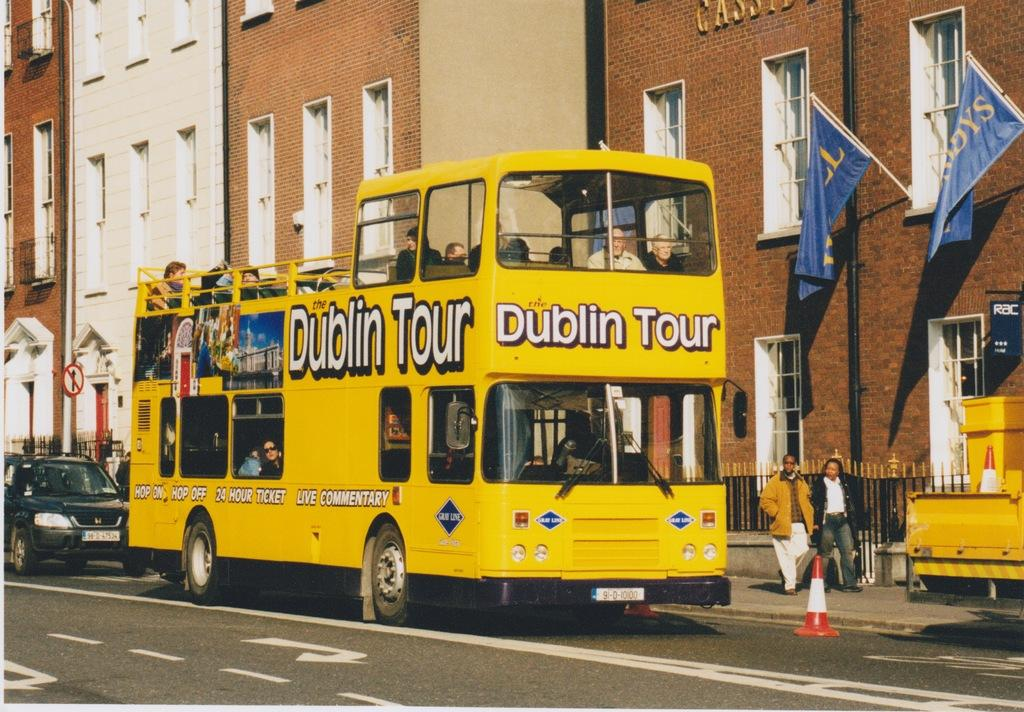<image>
Render a clear and concise summary of the photo. A yellow double decker Dublin Tour bus on a street 